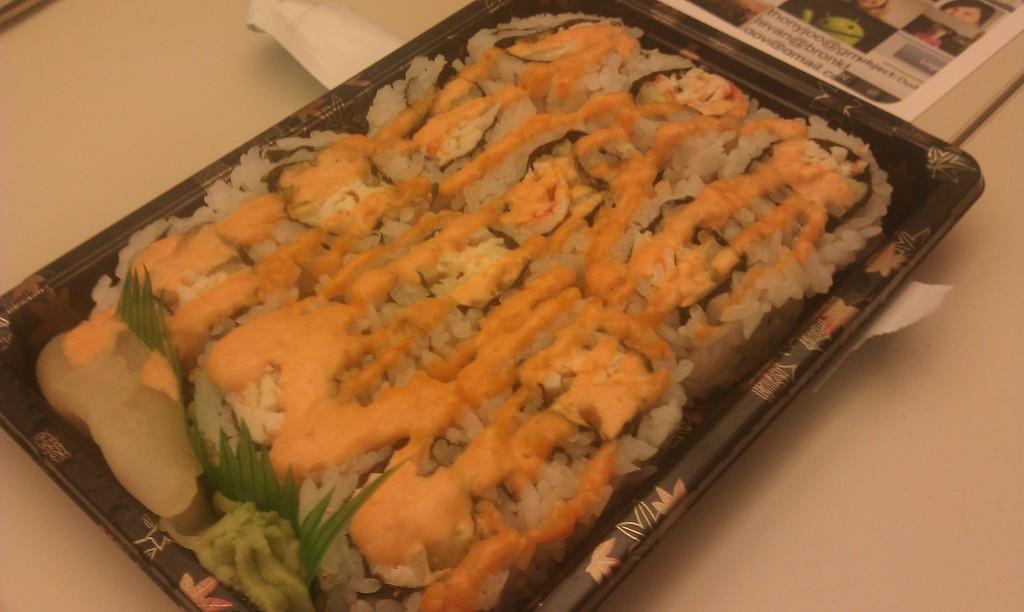Can you describe this image briefly? In this image we can see a food item is kept in a black color tray. Top of the image paper with some images is present. 